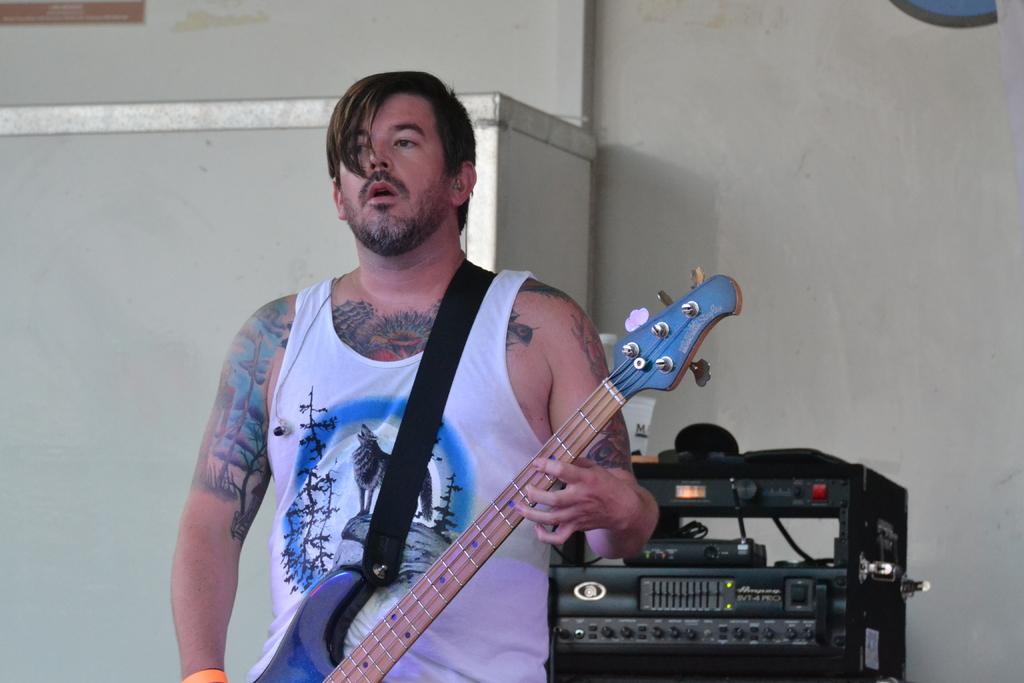What is the main subject of the image? There is a man in the image. What is the man doing in the image? The man is standing and holding a guitar. Can you describe any additional features of the man? The man has a tattoo on his hand. What else can be seen in the image besides the man? There is a machine visible in the image, as well as a white wall. What type of religious symbol can be seen on the man's tattoo in the image? There is no religious symbol present on the man's tattoo in the image. Can you describe the steam coming out of the machine in the image? There is no steam visible in the image; only a man holding a guitar, a machine, and a white wall are present. 